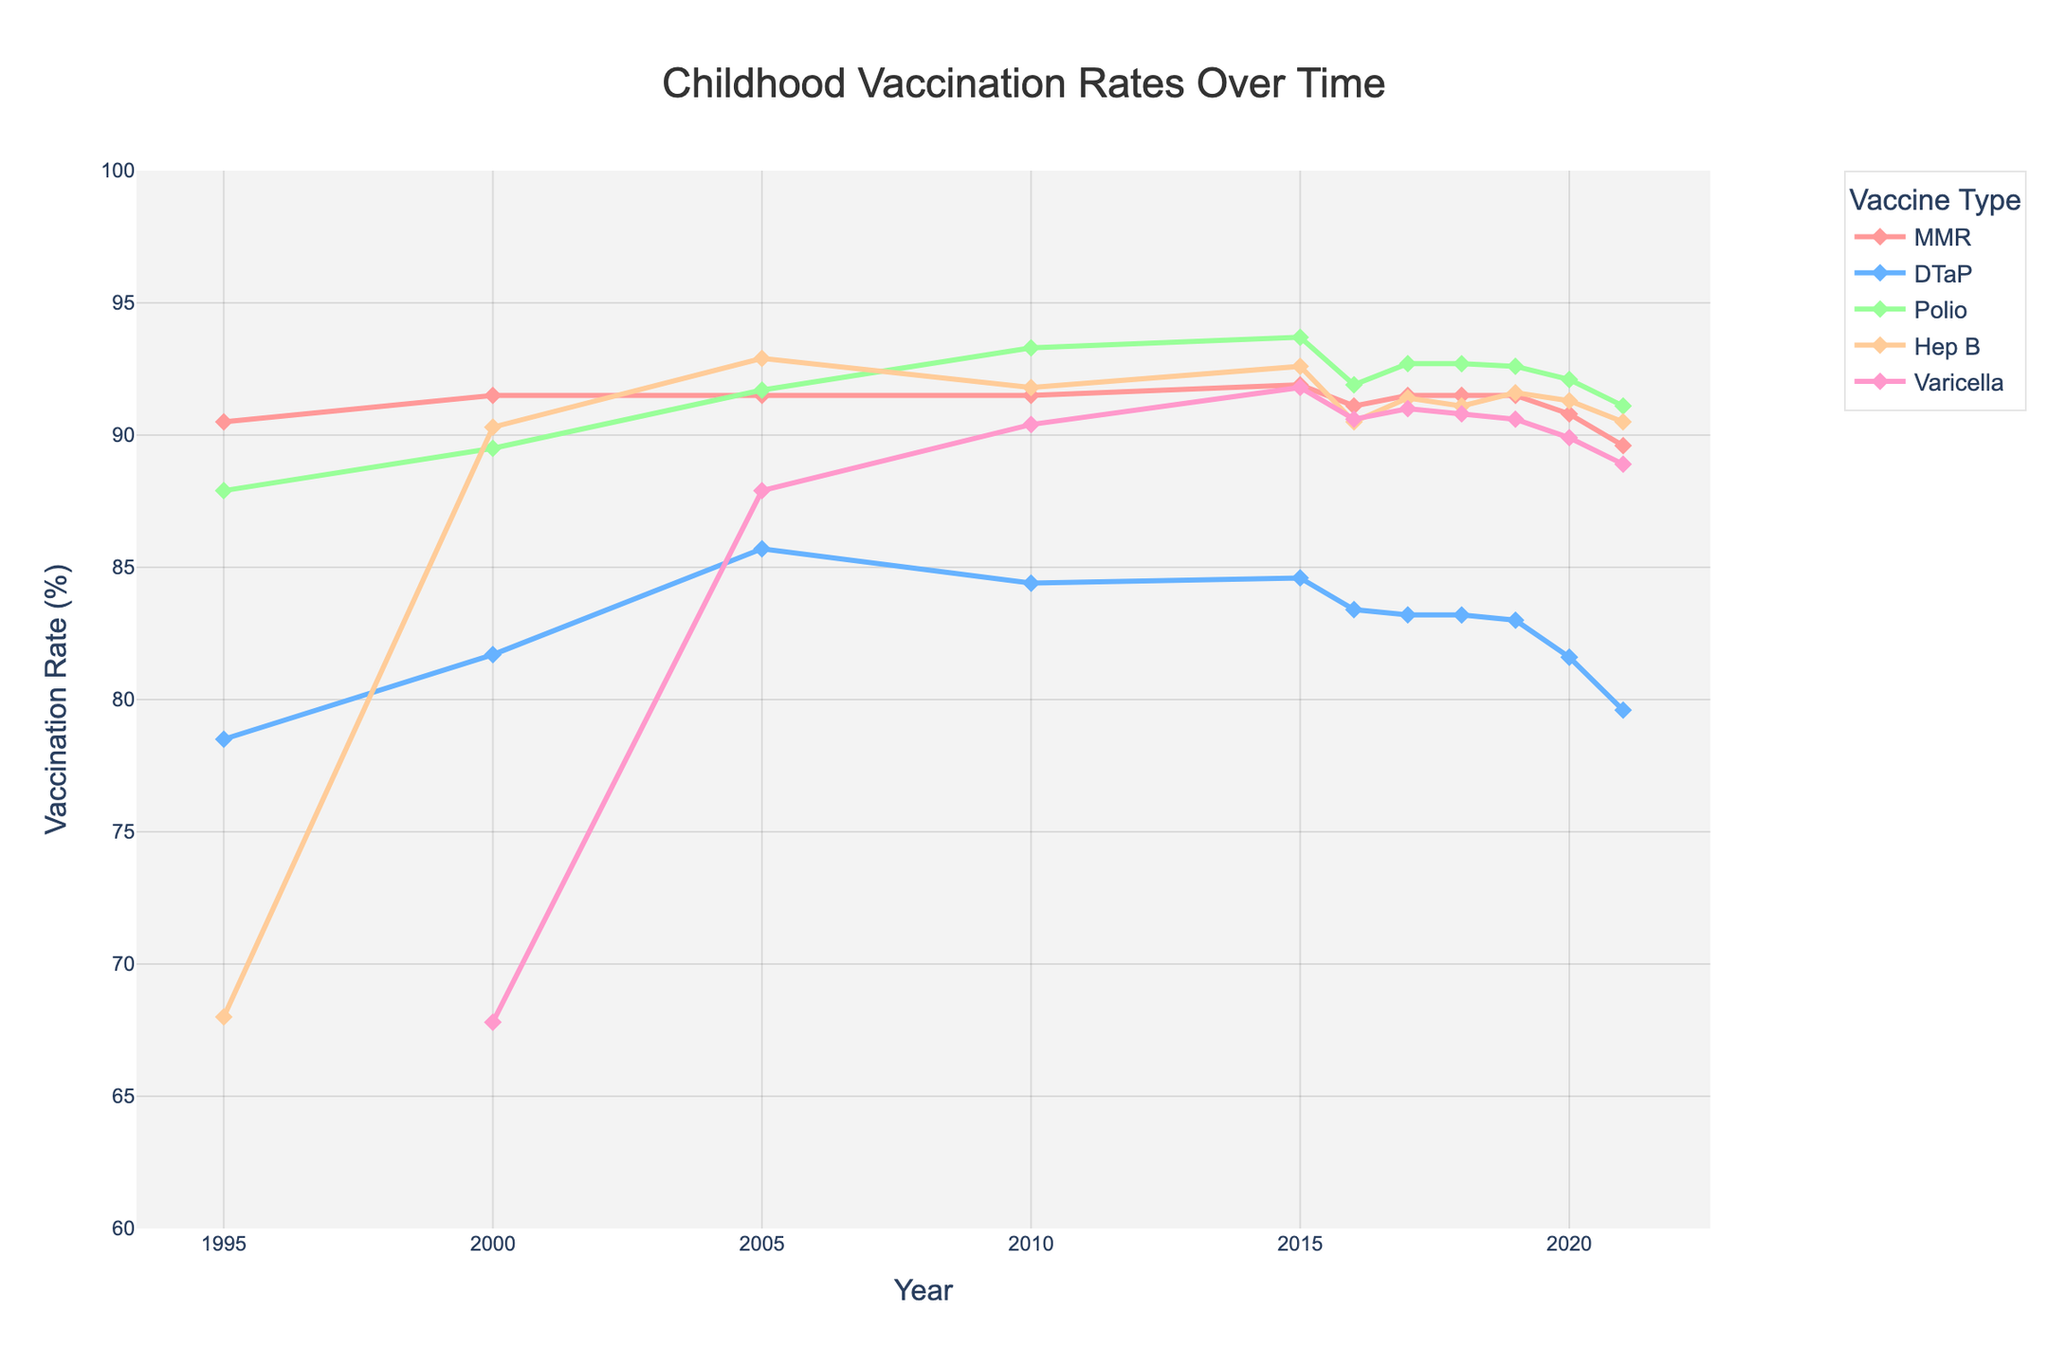What is the vaccination rate for MMR in the year 2015? Locate the MMR line on the plot and find the point corresponding to the year 2015. Read the value from the y-axis.
Answer: 91.9% Which vaccine had the highest vaccination rate in the year 2000? Look at the points for the year 2000 and compare the heights of the lines for each vaccine. The highest point represents the highest vaccination rate.
Answer: Hep B How did the vaccination rate for Varicella change from 2000 to 2010? Find the Varicella line and compare its y-values between the years 2000 and 2010. Note the increase or decrease.
Answer: Increased Which two vaccines had similar vaccination rates in 2020? Compare the lines for different vaccines in the year 2020 and find the lines that are closest in height.
Answer: DTaP and Varicella What is the overall trend for Polio vaccination rates from 1995 to 2021? Follow the Polio line from 1995 to 2021, noting any general increase, decrease, or stability.
Answer: Mostly increasing Compare the vaccination rates of MMR and Hep B in 2021. Which one is higher? Look at the points for the year 2021 for both MMR and Hep B and compare their y-values.
Answer: Hep B Determine the average vaccination rate of MMR from 1995 to 2021. Sum the vaccination rates of MMR for all years and divide by the number of years (11).
Answer: 91.27% In which year did DTaP vaccination rates peak? Find the highest point on the DTaP line and note the corresponding year.
Answer: 2005 How did the vaccination rates for DTaP and Polio compare in the year 2005? Locate the points for DTaP and Polio in the year 2005 and compare their y-values.
Answer: DTaP: 85.7, Polio: 91.7 What is the color representing MMR vaccination rates? Identify the color of the line and markers used for MMR on the plot.
Answer: Red 